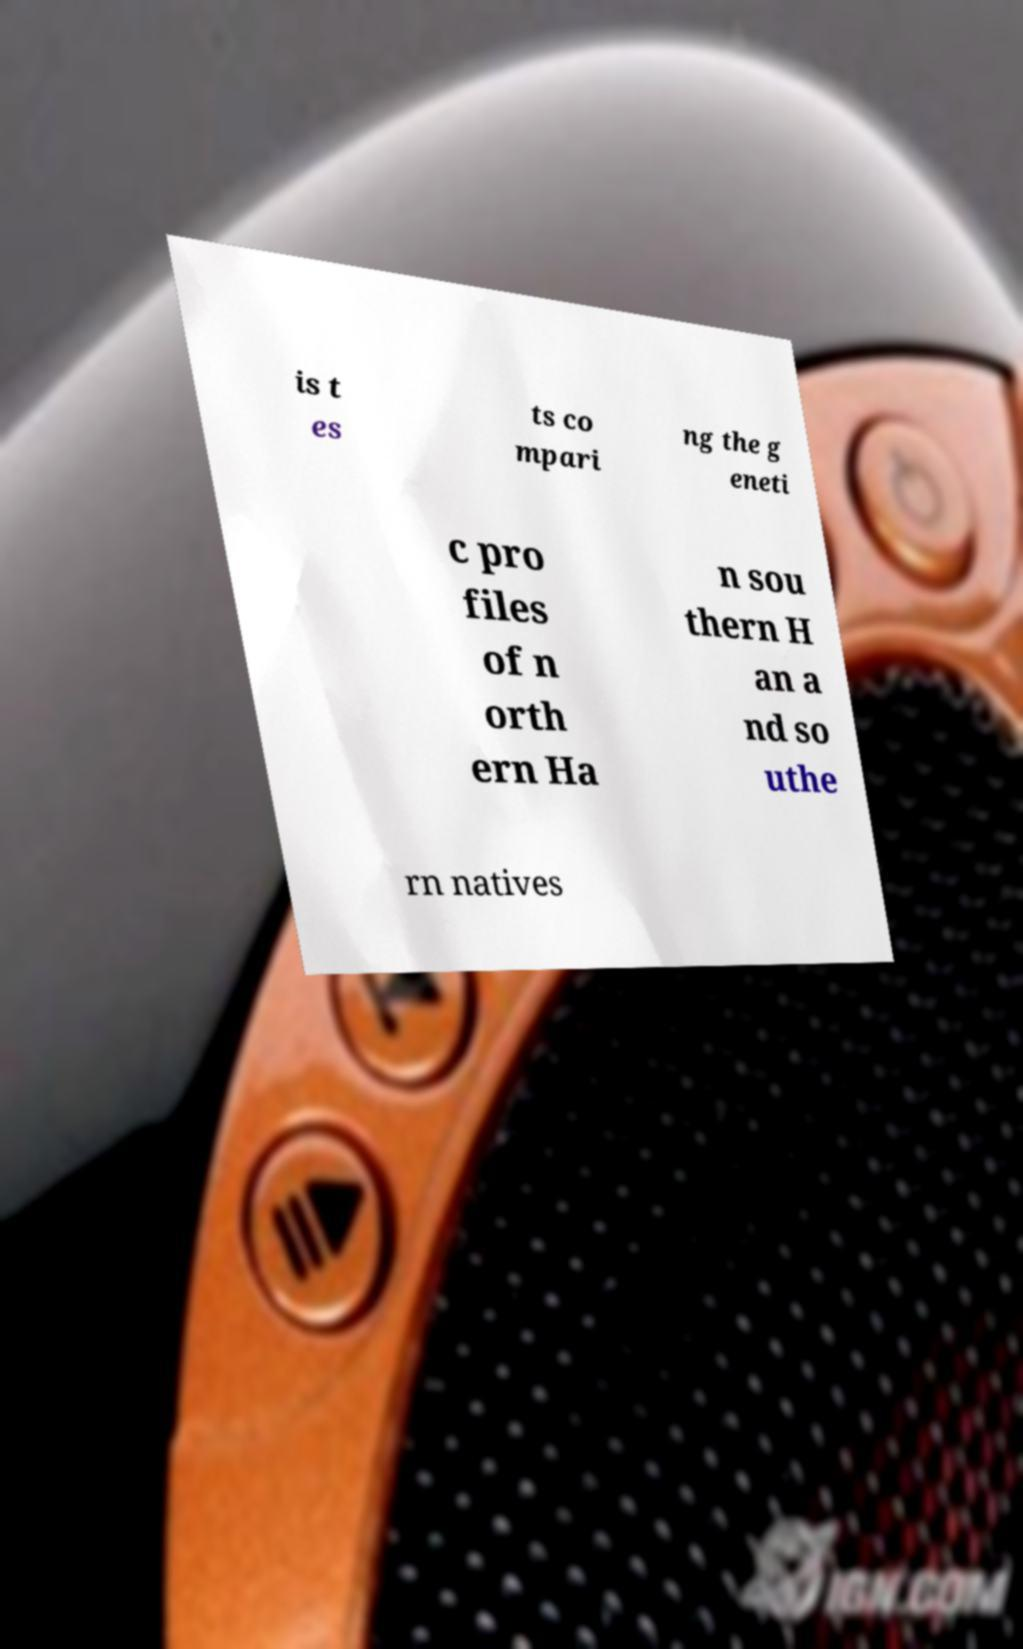For documentation purposes, I need the text within this image transcribed. Could you provide that? is t es ts co mpari ng the g eneti c pro files of n orth ern Ha n sou thern H an a nd so uthe rn natives 